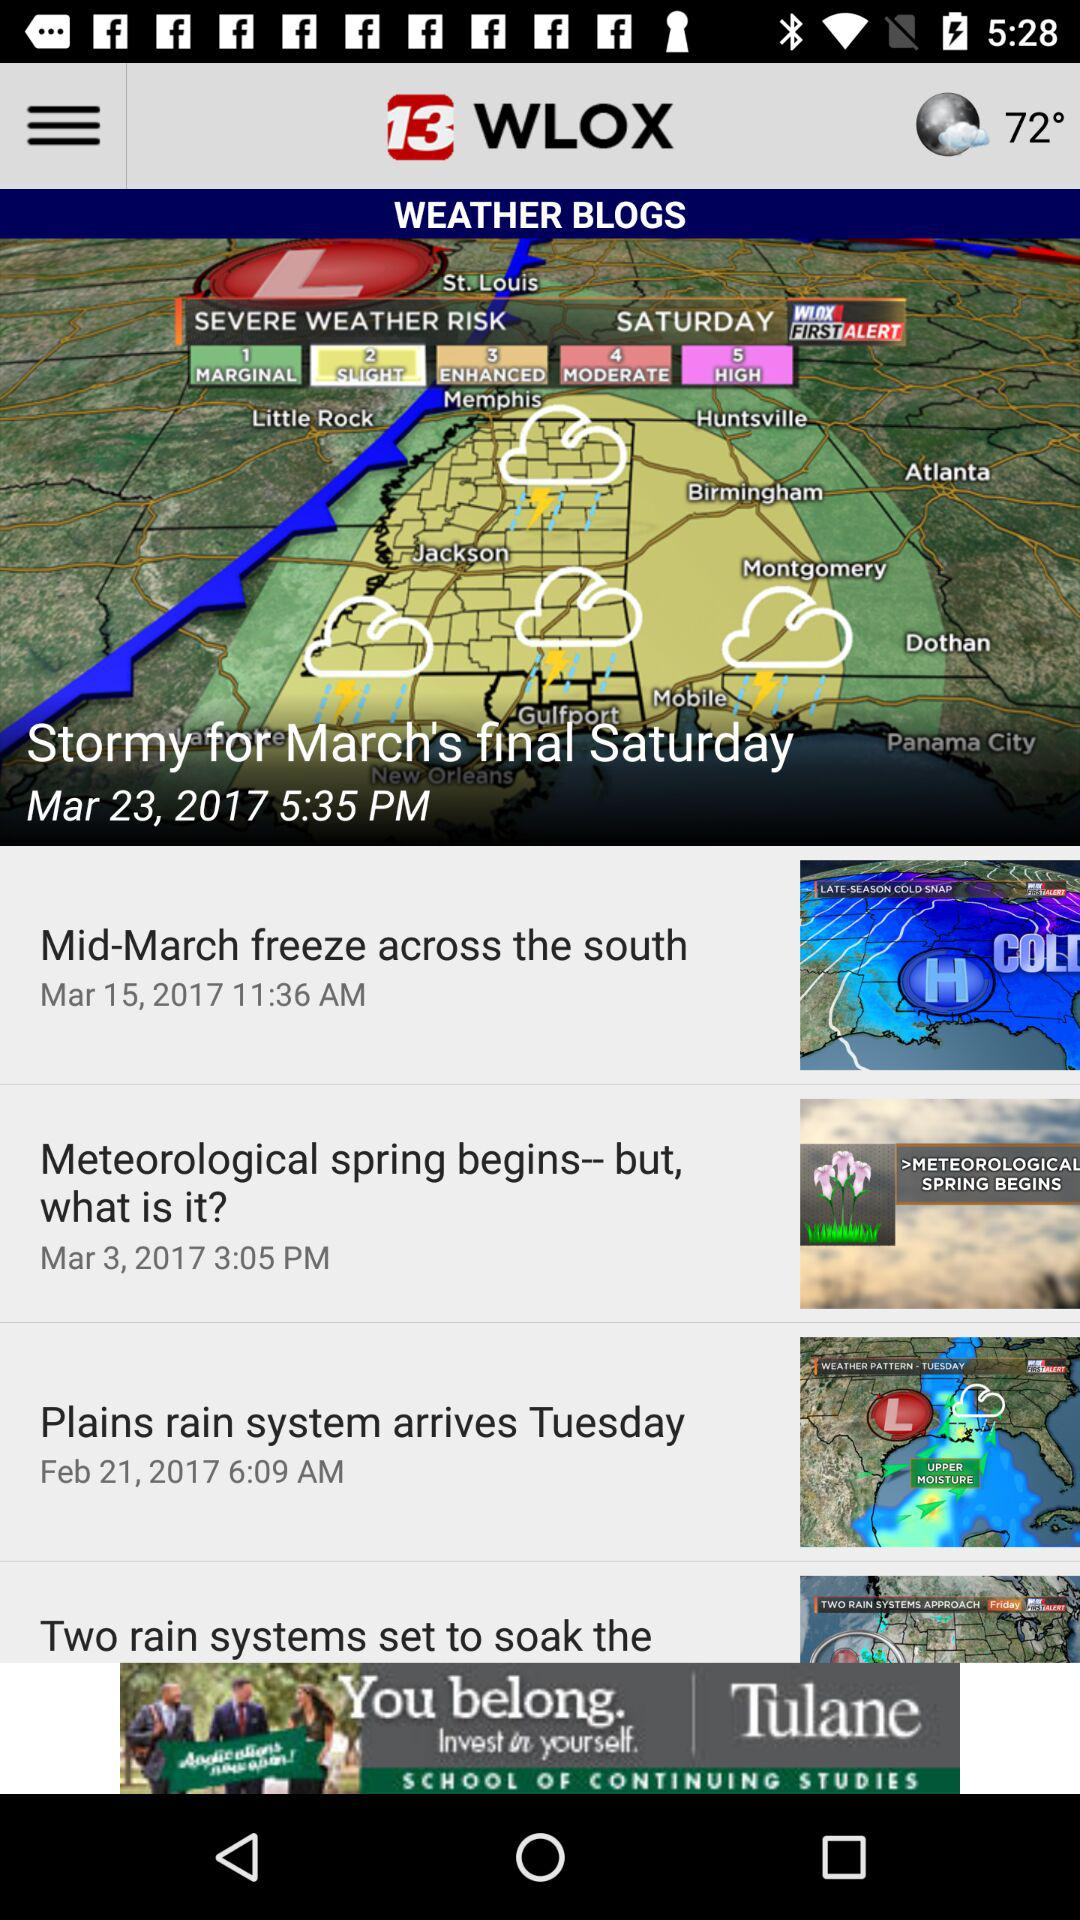What is the posted time of "Stormy for March's final Saturday"? The posted time of "Stormy for March's final Saturday" is 5:35 PM. 